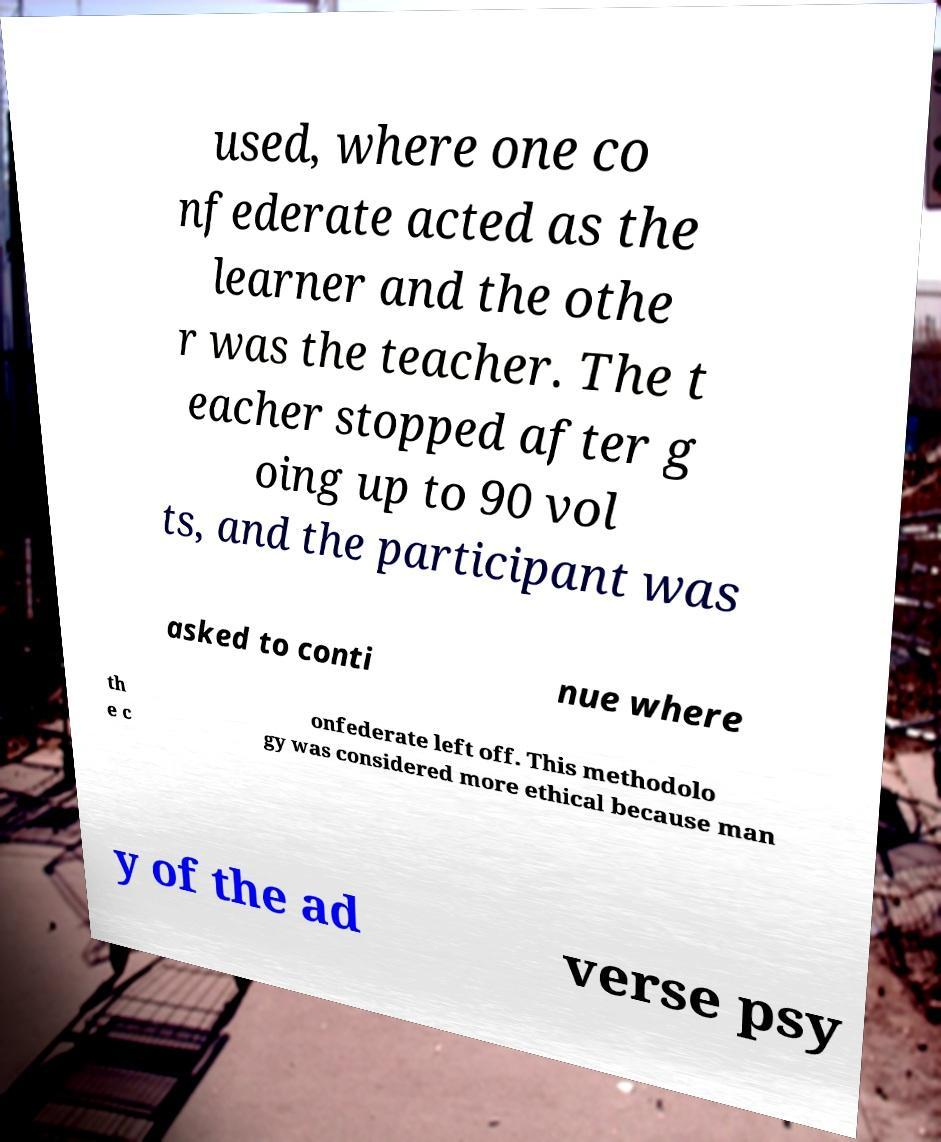Could you extract and type out the text from this image? used, where one co nfederate acted as the learner and the othe r was the teacher. The t eacher stopped after g oing up to 90 vol ts, and the participant was asked to conti nue where th e c onfederate left off. This methodolo gy was considered more ethical because man y of the ad verse psy 